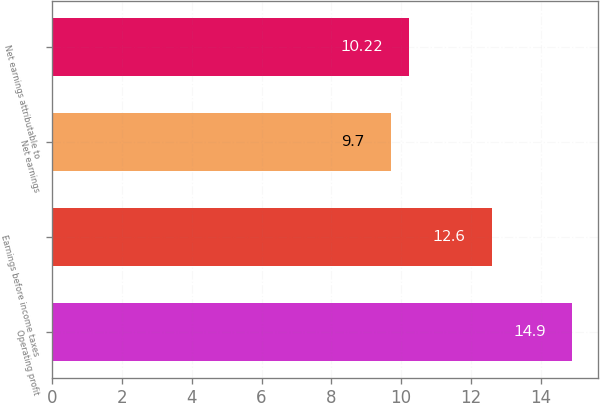<chart> <loc_0><loc_0><loc_500><loc_500><bar_chart><fcel>Operating profit<fcel>Earnings before income taxes<fcel>Net earnings<fcel>Net earnings attributable to<nl><fcel>14.9<fcel>12.6<fcel>9.7<fcel>10.22<nl></chart> 